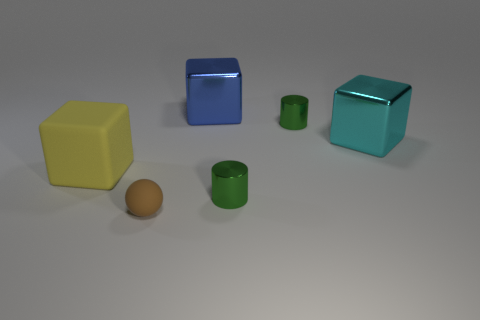How is the lighting affecting the appearance of the objects? The lighting creates highlights and shadows that define the dimensions and contours of the objects, as well as their texture. The reflective objects show sharp specular highlights, while the matte ball has a more diffused reflection, indicating a less direct light source. 